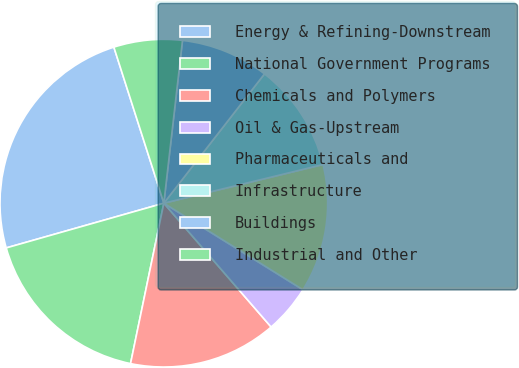<chart> <loc_0><loc_0><loc_500><loc_500><pie_chart><fcel>Energy & Refining-Downstream<fcel>National Government Programs<fcel>Chemicals and Polymers<fcel>Oil & Gas-Upstream<fcel>Pharmaceuticals and<fcel>Infrastructure<fcel>Buildings<fcel>Industrial and Other<nl><fcel>24.47%<fcel>17.34%<fcel>14.62%<fcel>4.78%<fcel>12.65%<fcel>10.68%<fcel>8.71%<fcel>6.75%<nl></chart> 